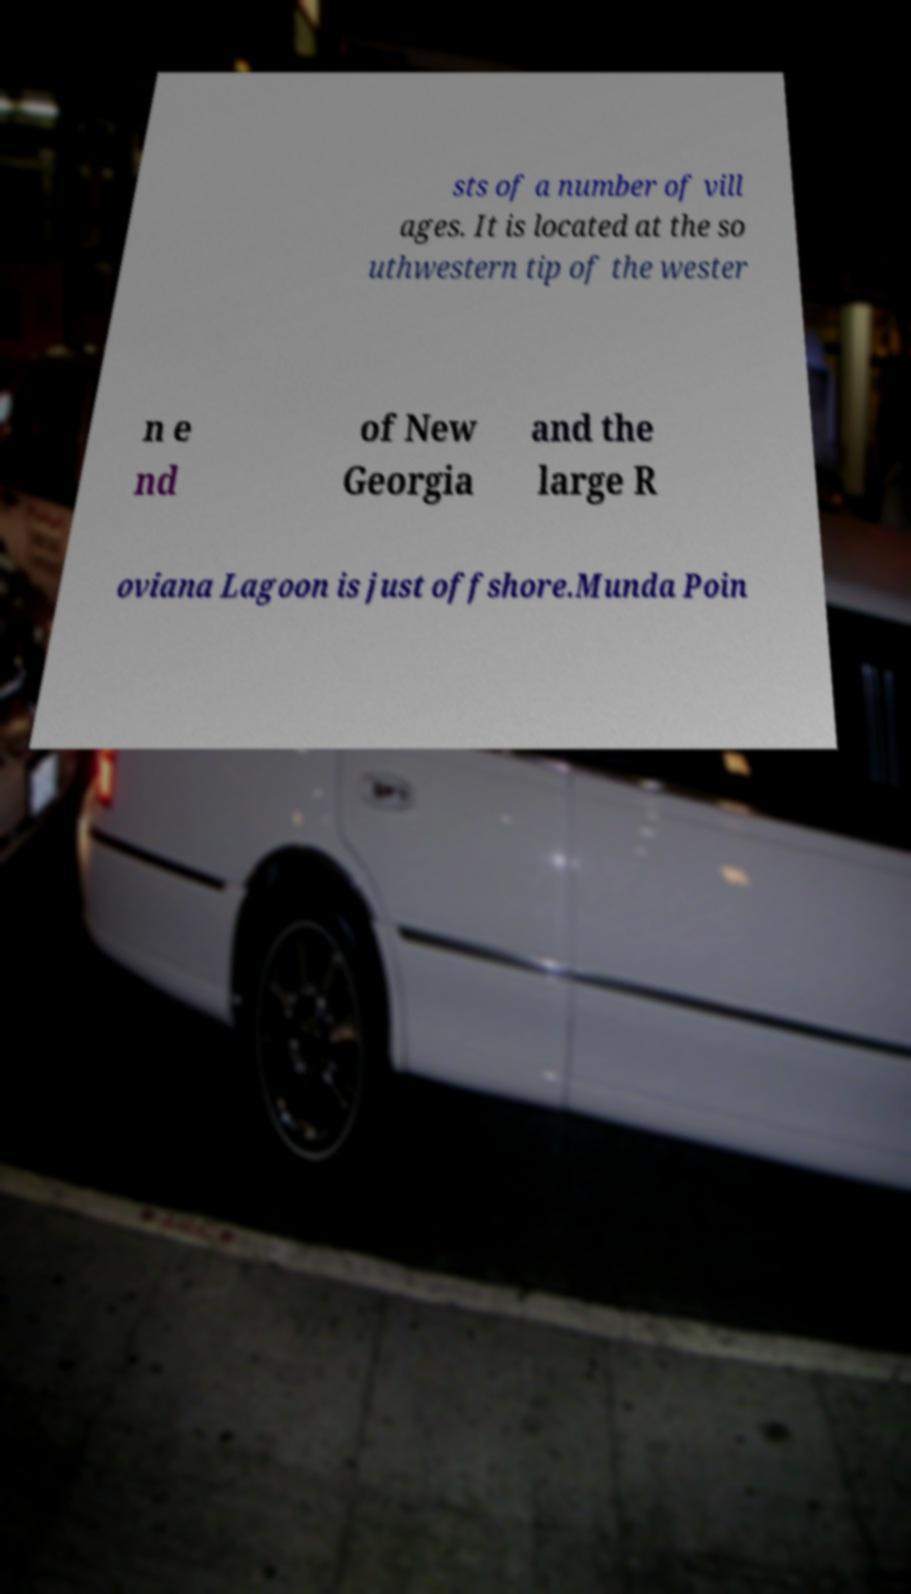What messages or text are displayed in this image? I need them in a readable, typed format. sts of a number of vill ages. It is located at the so uthwestern tip of the wester n e nd of New Georgia and the large R oviana Lagoon is just offshore.Munda Poin 